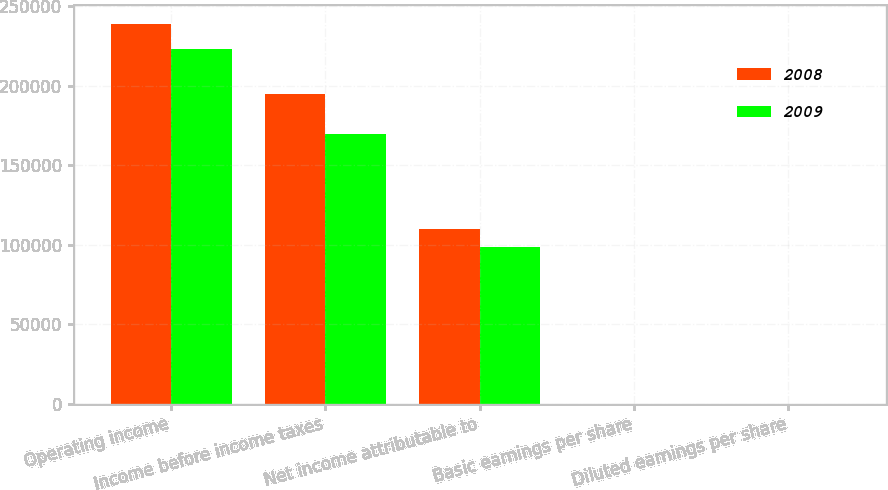Convert chart. <chart><loc_0><loc_0><loc_500><loc_500><stacked_bar_chart><ecel><fcel>Operating income<fcel>Income before income taxes<fcel>Net income attributable to<fcel>Basic earnings per share<fcel>Diluted earnings per share<nl><fcel>2008<fcel>238712<fcel>194563<fcel>109724<fcel>1.07<fcel>1.06<nl><fcel>2009<fcel>223109<fcel>169364<fcel>98365<fcel>0.95<fcel>0.94<nl></chart> 